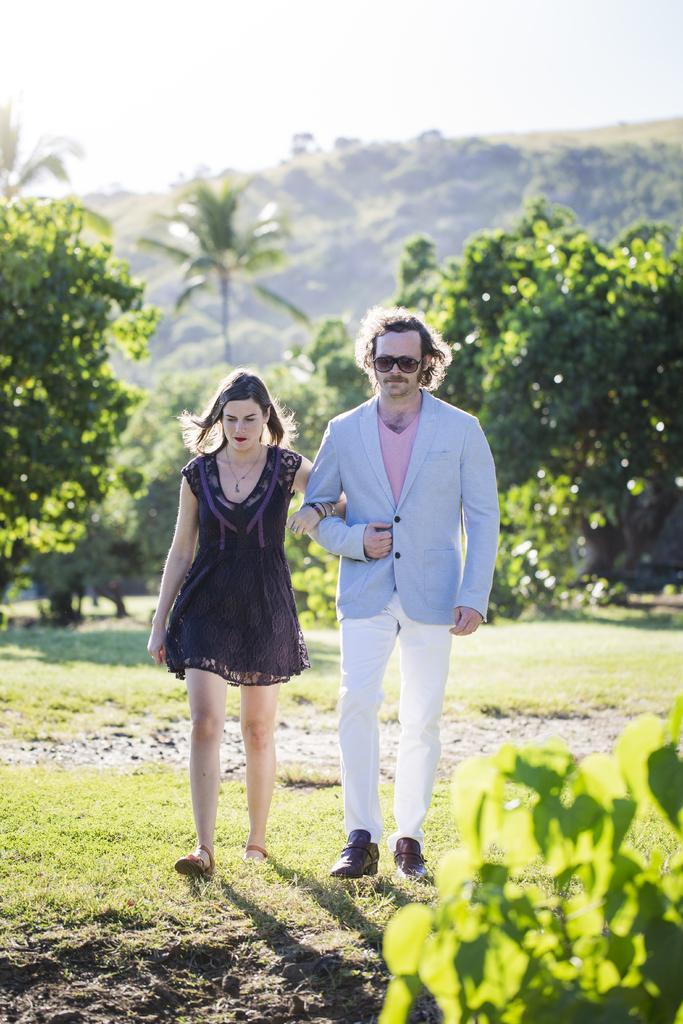How would you summarize this image in a sentence or two? In the center of the image we can see two persons are walking and they are in different costumes. And the right side person is wearing sunglasses. In the background, we can see the sky, clouds, hills, trees, plants, grass etc. 